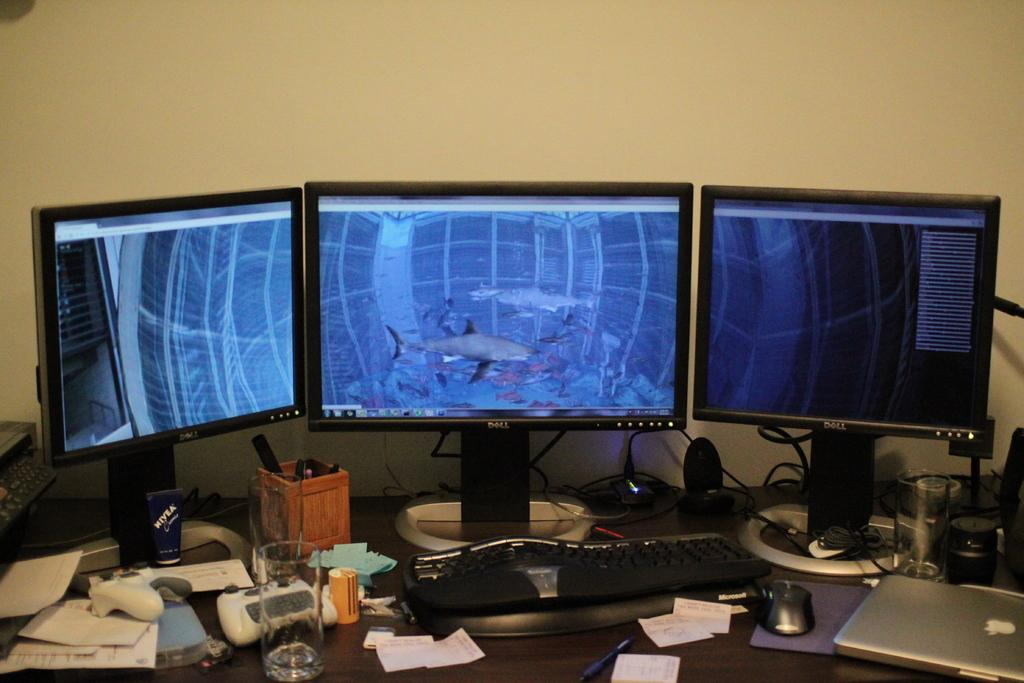What type of furniture is present in the image? There is a table in the image. What electronic devices are on the table? There are computers, a laptop, a keyboard, a mouse, speakers, and wires on the table. What stationery items are on the table? There are papers, pens, and glasses on the table. What type of rail can be seen in the image? There is no rail present in the image. What type of cream is being used on the table in the image? There is no cream present in the image. 